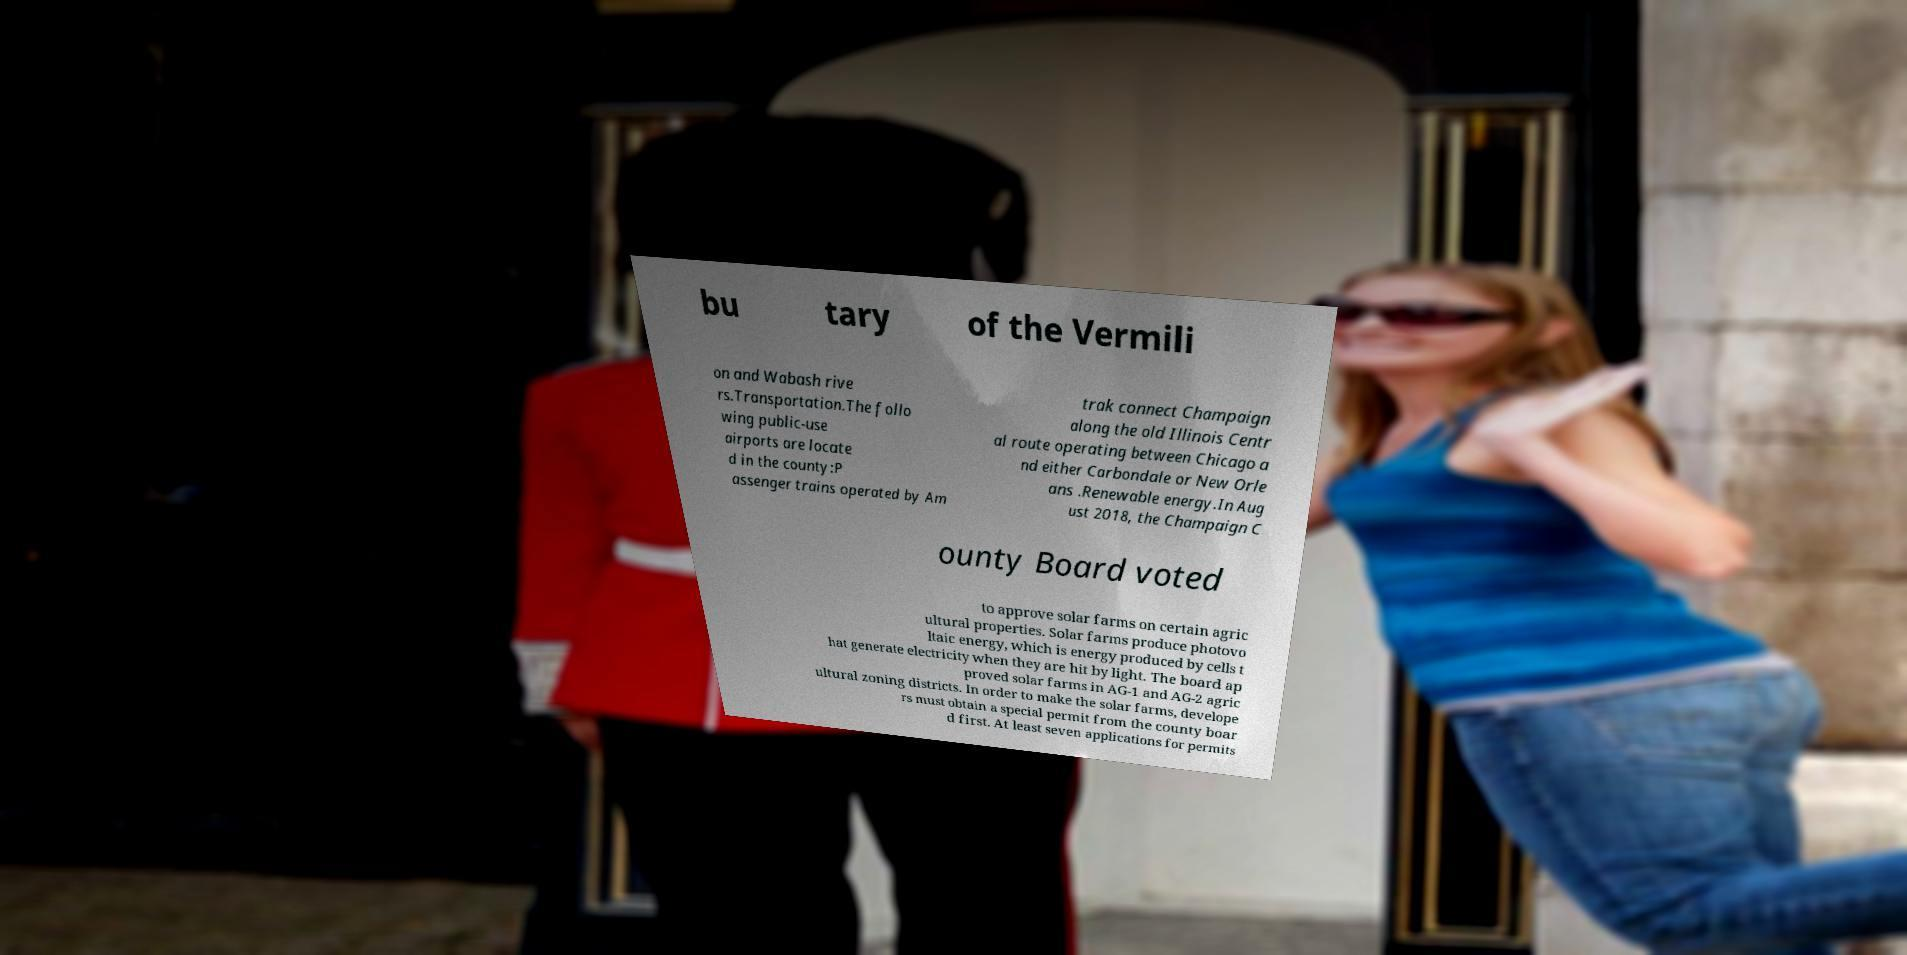Please read and relay the text visible in this image. What does it say? bu tary of the Vermili on and Wabash rive rs.Transportation.The follo wing public-use airports are locate d in the county:P assenger trains operated by Am trak connect Champaign along the old Illinois Centr al route operating between Chicago a nd either Carbondale or New Orle ans .Renewable energy.In Aug ust 2018, the Champaign C ounty Board voted to approve solar farms on certain agric ultural properties. Solar farms produce photovo ltaic energy, which is energy produced by cells t hat generate electricity when they are hit by light. The board ap proved solar farms in AG-1 and AG-2 agric ultural zoning districts. In order to make the solar farms, develope rs must obtain a special permit from the county boar d first. At least seven applications for permits 